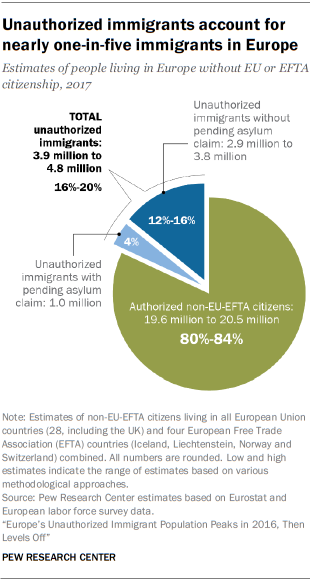Specify some key components in this picture. The largest pie is 0.84 and above. What is the percentage of light blue color in the range of 4% to 8%? 